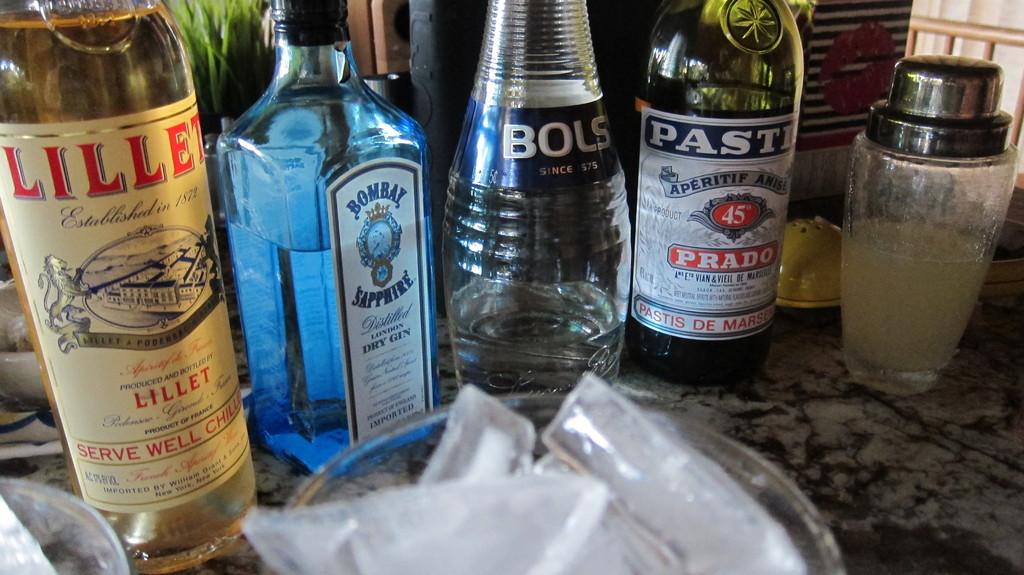What kind of drink is the one on the far left?
Give a very brief answer. Lillet. 